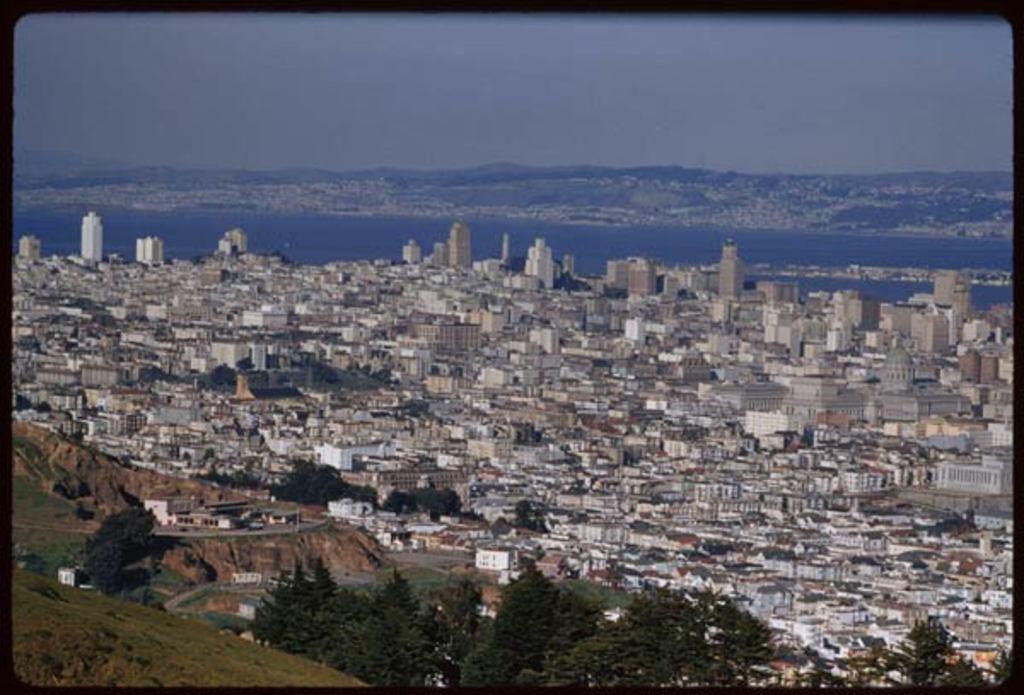How would you summarize this image in a sentence or two? In this image we can see a many buildings and houses ,In this image we can see a tree and a hill. 